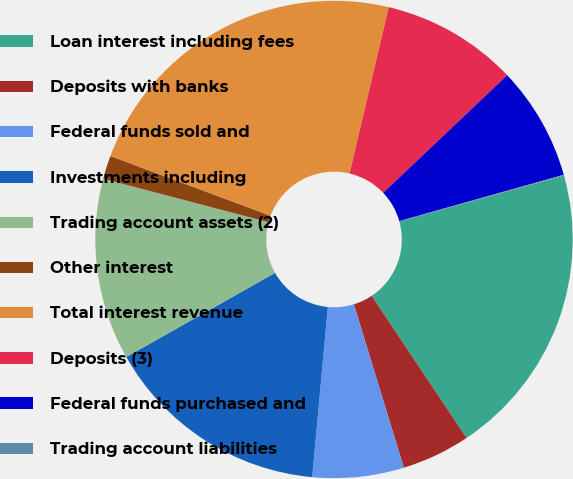<chart> <loc_0><loc_0><loc_500><loc_500><pie_chart><fcel>Loan interest including fees<fcel>Deposits with banks<fcel>Federal funds sold and<fcel>Investments including<fcel>Trading account assets (2)<fcel>Other interest<fcel>Total interest revenue<fcel>Deposits (3)<fcel>Federal funds purchased and<fcel>Trading account liabilities<nl><fcel>19.94%<fcel>4.65%<fcel>6.18%<fcel>15.35%<fcel>12.29%<fcel>1.59%<fcel>23.0%<fcel>9.24%<fcel>7.71%<fcel>0.06%<nl></chart> 